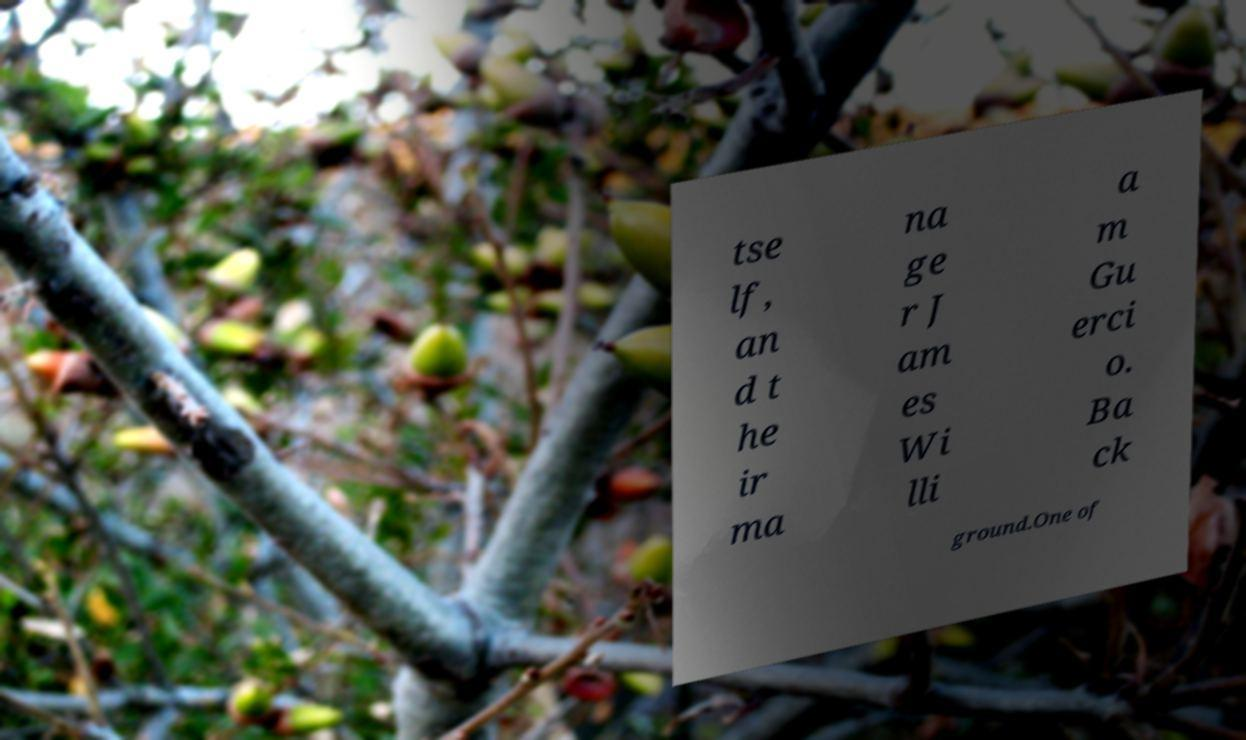What messages or text are displayed in this image? I need them in a readable, typed format. tse lf, an d t he ir ma na ge r J am es Wi lli a m Gu erci o. Ba ck ground.One of 